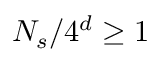Convert formula to latex. <formula><loc_0><loc_0><loc_500><loc_500>N _ { s } / 4 ^ { d } \geq 1</formula> 